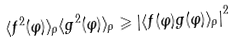<formula> <loc_0><loc_0><loc_500><loc_500>\langle f ^ { 2 } ( \varphi ) \rangle _ { \rho } \langle g ^ { 2 } ( \varphi ) \rangle _ { \rho } \geqslant \left | \langle f ( \varphi ) g ( \varphi ) \rangle _ { \rho } \right | ^ { 2 }</formula> 